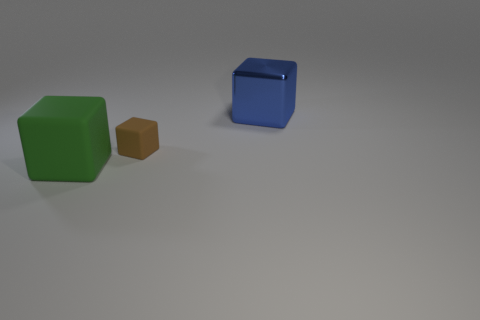Subtract all tiny brown rubber cubes. How many cubes are left? 2 Add 3 metal cubes. How many objects exist? 6 Subtract 2 cubes. How many cubes are left? 1 Subtract all blue cubes. How many cubes are left? 2 Subtract 0 red cylinders. How many objects are left? 3 Subtract all red cubes. Subtract all red balls. How many cubes are left? 3 Subtract all purple cylinders. How many green blocks are left? 1 Subtract all gray blocks. Subtract all large green things. How many objects are left? 2 Add 3 large green rubber objects. How many large green rubber objects are left? 4 Add 1 big blue metallic objects. How many big blue metallic objects exist? 2 